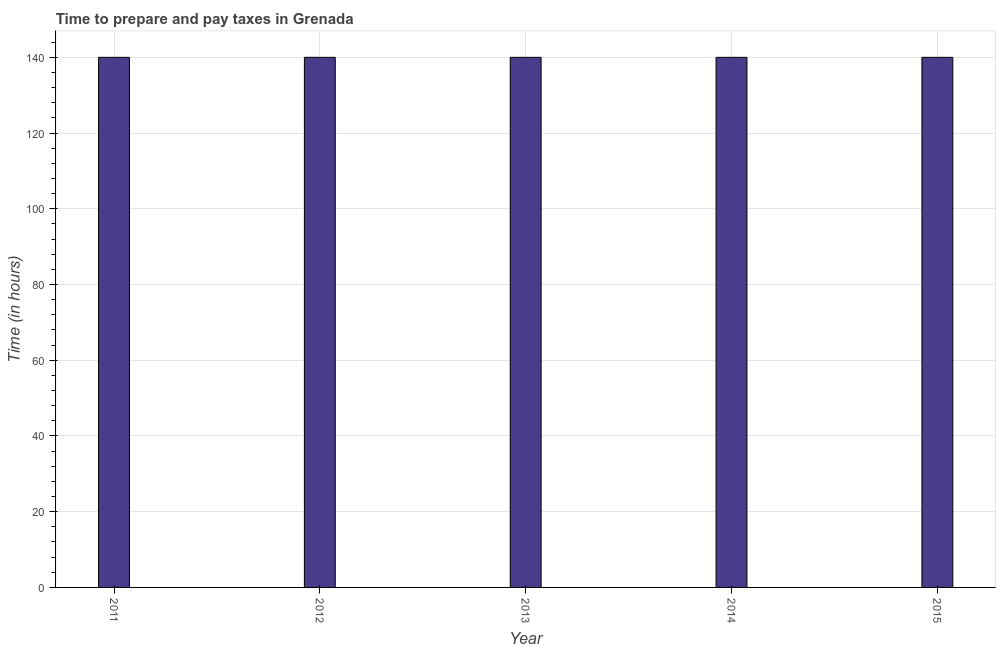Does the graph contain any zero values?
Make the answer very short. No. What is the title of the graph?
Your response must be concise. Time to prepare and pay taxes in Grenada. What is the label or title of the Y-axis?
Your answer should be compact. Time (in hours). What is the time to prepare and pay taxes in 2015?
Offer a very short reply. 140. Across all years, what is the maximum time to prepare and pay taxes?
Provide a short and direct response. 140. Across all years, what is the minimum time to prepare and pay taxes?
Ensure brevity in your answer.  140. In which year was the time to prepare and pay taxes maximum?
Provide a succinct answer. 2011. What is the sum of the time to prepare and pay taxes?
Your answer should be compact. 700. What is the average time to prepare and pay taxes per year?
Offer a terse response. 140. What is the median time to prepare and pay taxes?
Ensure brevity in your answer.  140. In how many years, is the time to prepare and pay taxes greater than 124 hours?
Keep it short and to the point. 5. Do a majority of the years between 2013 and 2012 (inclusive) have time to prepare and pay taxes greater than 28 hours?
Offer a very short reply. No. Is the time to prepare and pay taxes in 2011 less than that in 2012?
Your answer should be very brief. No. Is the sum of the time to prepare and pay taxes in 2012 and 2014 greater than the maximum time to prepare and pay taxes across all years?
Keep it short and to the point. Yes. What is the difference between the highest and the lowest time to prepare and pay taxes?
Your answer should be very brief. 0. Are all the bars in the graph horizontal?
Keep it short and to the point. No. What is the difference between two consecutive major ticks on the Y-axis?
Your answer should be very brief. 20. Are the values on the major ticks of Y-axis written in scientific E-notation?
Provide a succinct answer. No. What is the Time (in hours) of 2011?
Give a very brief answer. 140. What is the Time (in hours) of 2012?
Provide a short and direct response. 140. What is the Time (in hours) of 2013?
Make the answer very short. 140. What is the Time (in hours) of 2014?
Provide a succinct answer. 140. What is the Time (in hours) of 2015?
Offer a very short reply. 140. What is the difference between the Time (in hours) in 2011 and 2012?
Give a very brief answer. 0. What is the difference between the Time (in hours) in 2011 and 2015?
Your answer should be compact. 0. What is the difference between the Time (in hours) in 2012 and 2013?
Offer a terse response. 0. What is the difference between the Time (in hours) in 2012 and 2014?
Make the answer very short. 0. What is the difference between the Time (in hours) in 2012 and 2015?
Give a very brief answer. 0. What is the difference between the Time (in hours) in 2013 and 2015?
Ensure brevity in your answer.  0. What is the ratio of the Time (in hours) in 2011 to that in 2013?
Give a very brief answer. 1. What is the ratio of the Time (in hours) in 2011 to that in 2014?
Your answer should be compact. 1. What is the ratio of the Time (in hours) in 2012 to that in 2013?
Make the answer very short. 1. What is the ratio of the Time (in hours) in 2012 to that in 2014?
Provide a short and direct response. 1. What is the ratio of the Time (in hours) in 2012 to that in 2015?
Keep it short and to the point. 1. What is the ratio of the Time (in hours) in 2014 to that in 2015?
Provide a succinct answer. 1. 